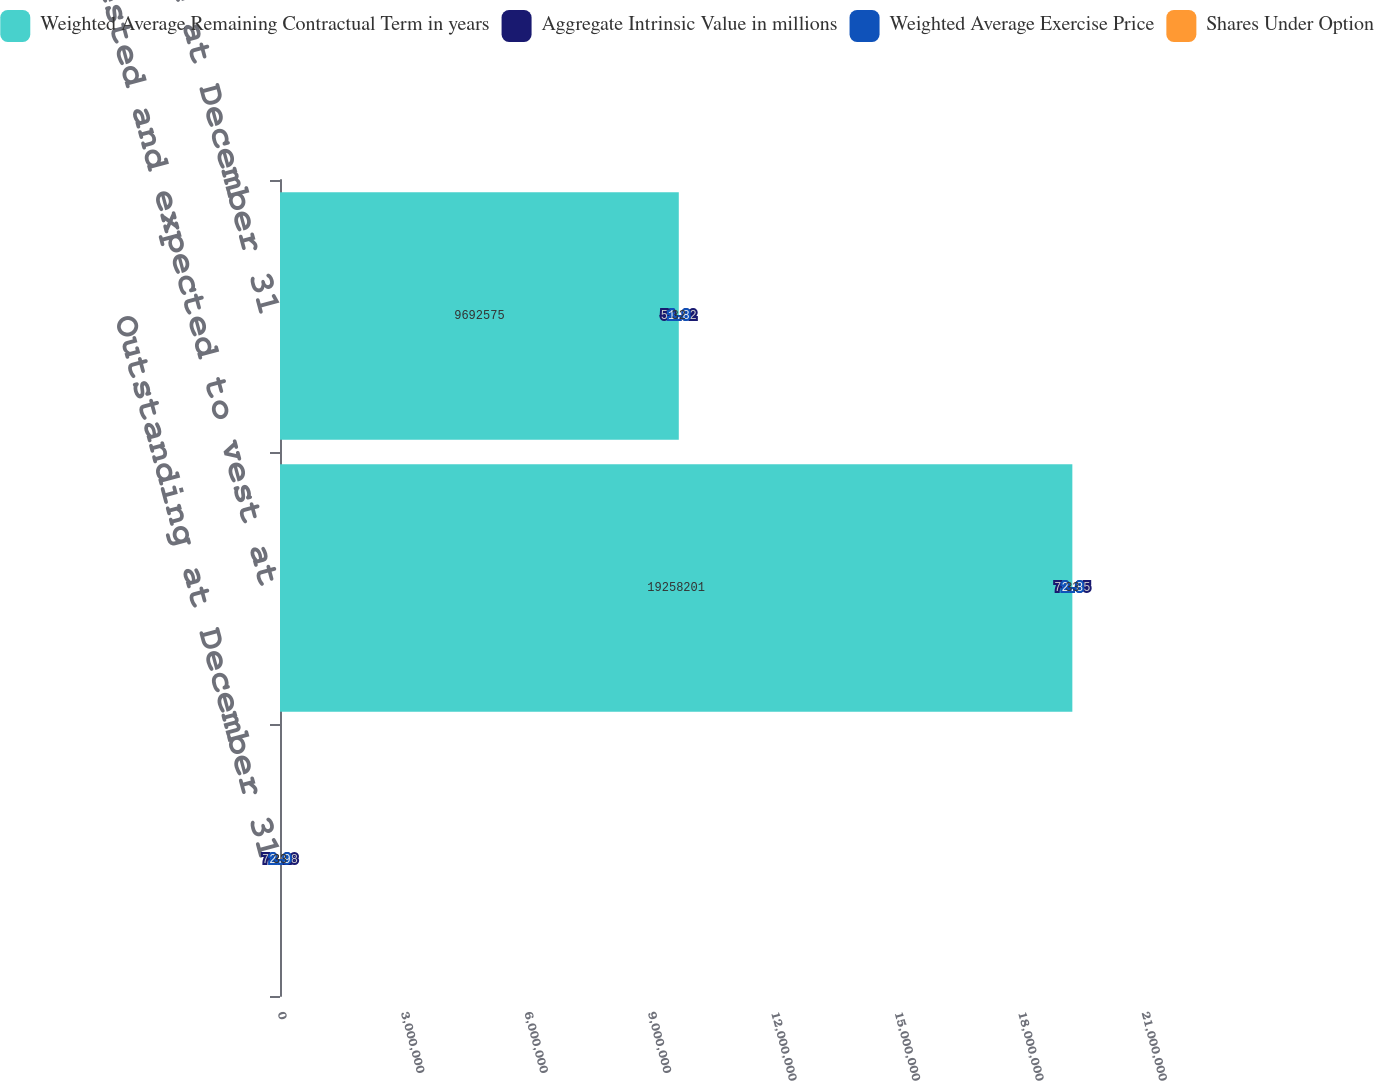Convert chart to OTSL. <chart><loc_0><loc_0><loc_500><loc_500><stacked_bar_chart><ecel><fcel>Outstanding at December 31<fcel>Vested and expected to vest at<fcel>Exercisable at December 31<nl><fcel>Weighted Average Remaining Contractual Term in years<fcel>33<fcel>1.92582e+07<fcel>9.69258e+06<nl><fcel>Aggregate Intrinsic Value in millions<fcel>70.28<fcel>70.05<fcel>59.92<nl><fcel>Weighted Average Exercise Price<fcel>2.9<fcel>2.8<fcel>1.8<nl><fcel>Shares Under Option<fcel>33<fcel>33<fcel>32<nl></chart> 